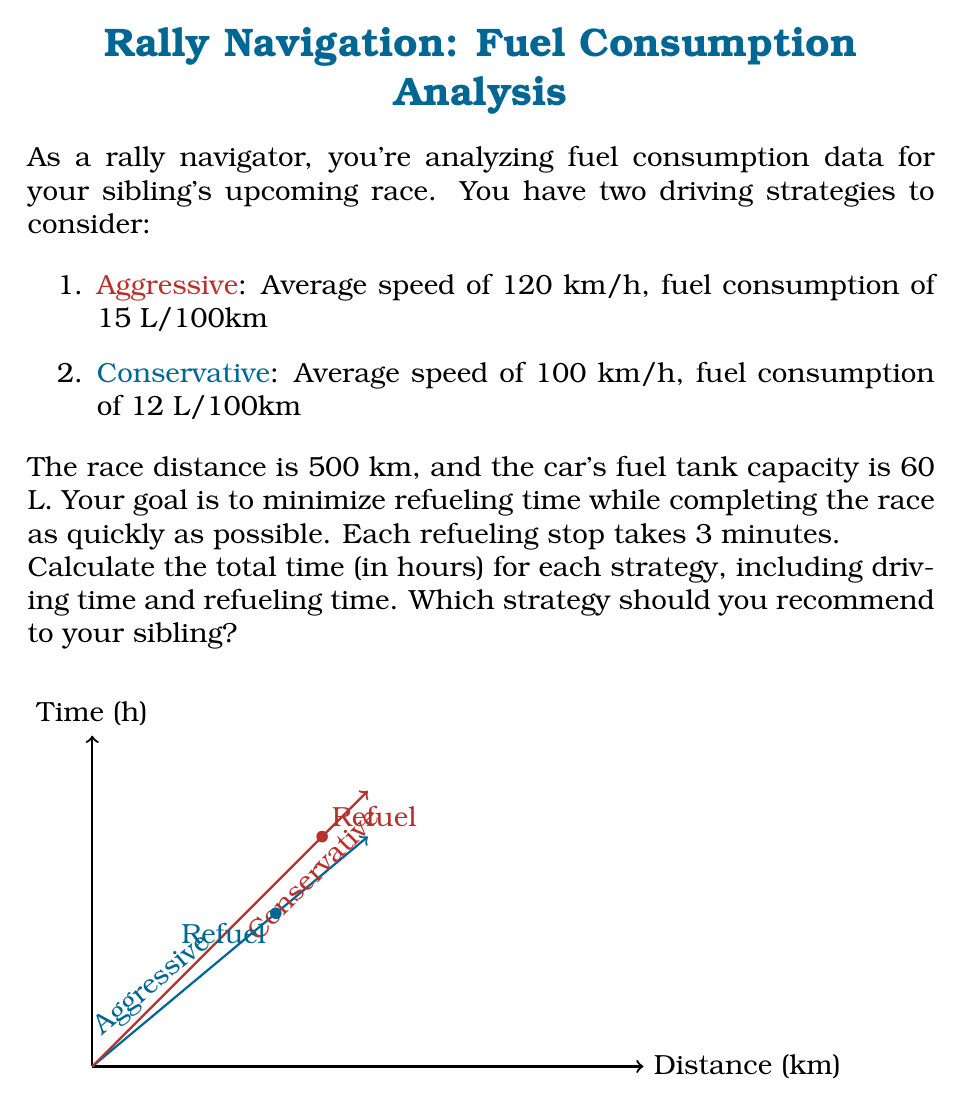Show me your answer to this math problem. Let's analyze each strategy step-by-step:

1. Aggressive Strategy:
   a) Driving time: 
      $T_d = \frac{Distance}{Speed} = \frac{500 \text{ km}}{120 \text{ km/h}} = 4.17 \text{ hours}$
   
   b) Fuel consumed: 
      $F_c = 500 \text{ km} \times \frac{15 \text{ L}}{100 \text{ km}} = 75 \text{ L}$
   
   c) Number of refueling stops: 
      $N_r = \left\lceil\frac{75 \text{ L}}{60 \text{ L}}\right\rceil - 1 = 1$ (one stop, as we start with a full tank)
   
   d) Refueling time: 
      $T_r = 1 \times 3 \text{ minutes} = 3 \text{ minutes} = 0.05 \text{ hours}$
   
   e) Total time: 
      $T_t = T_d + T_r = 4.17 + 0.05 = 4.22 \text{ hours}$

2. Conservative Strategy:
   a) Driving time: 
      $T_d = \frac{Distance}{Speed} = \frac{500 \text{ km}}{100 \text{ km/h}} = 5 \text{ hours}$
   
   b) Fuel consumed: 
      $F_c = 500 \text{ km} \times \frac{12 \text{ L}}{100 \text{ km}} = 60 \text{ L}$
   
   c) Number of refueling stops: 
      $N_r = \left\lceil\frac{60 \text{ L}}{60 \text{ L}}\right\rceil - 1 = 0$ (no stops needed)
   
   d) Refueling time: 
      $T_r = 0 \text{ hours}$
   
   e) Total time: 
      $T_t = T_d + T_r = 5 + 0 = 5 \text{ hours}$

Comparing the two strategies:
- Aggressive: 4.22 hours
- Conservative: 5 hours

The aggressive strategy is faster by 0.78 hours (about 47 minutes).
Answer: Recommend the aggressive strategy (4.22 hours total). 